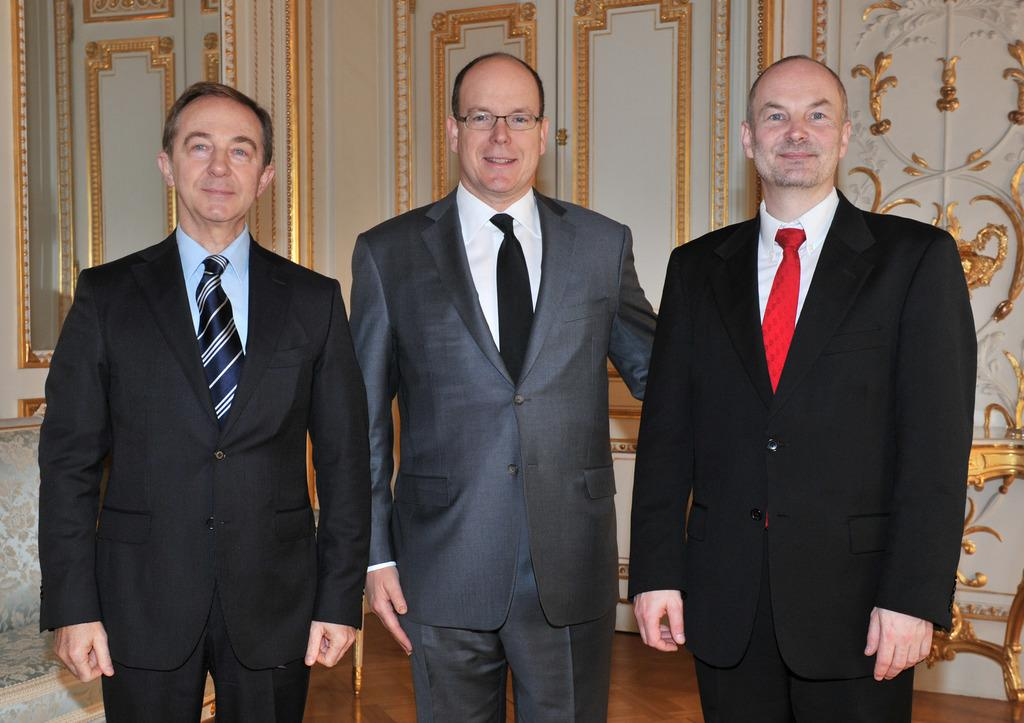How many people are in the image? There are three men in the image. What are the men wearing? The men are wearing suits and ties. What can be seen in the background of the image? There is a wall in the background of the image. What type of scissors can be seen in the image? There are no scissors present in the image. What advice are the men giving to each other in the image? There is no indication in the image that the men are giving advice to each other. 